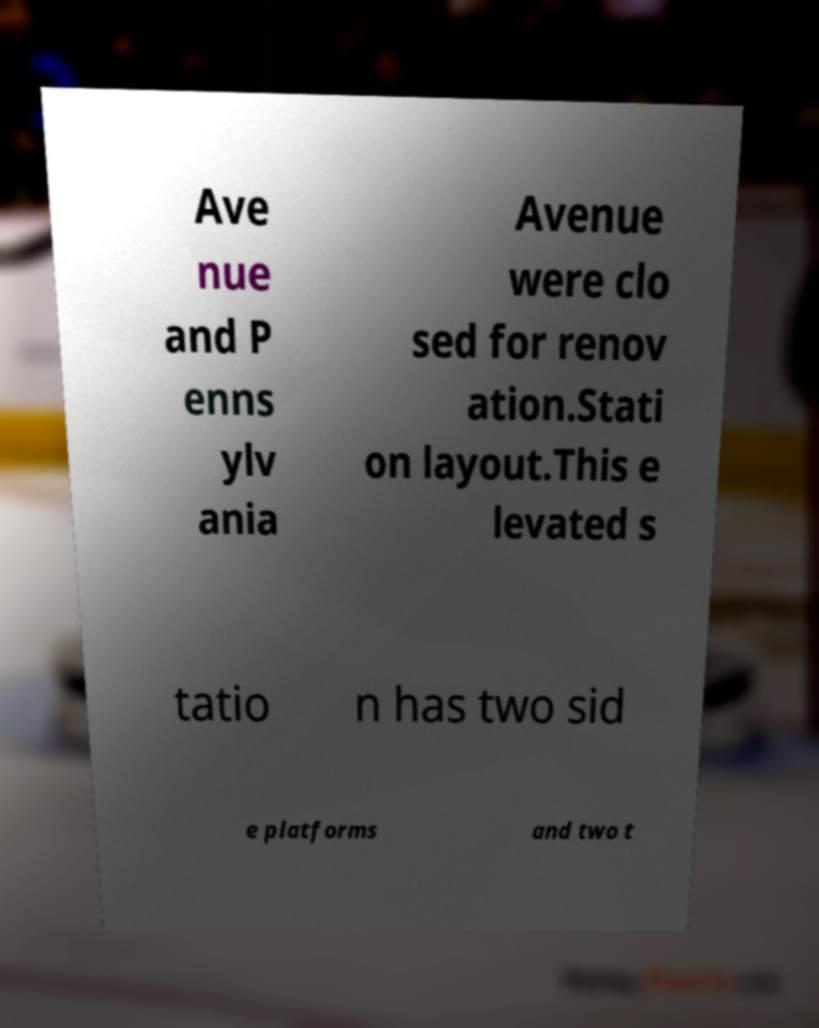What messages or text are displayed in this image? I need them in a readable, typed format. Ave nue and P enns ylv ania Avenue were clo sed for renov ation.Stati on layout.This e levated s tatio n has two sid e platforms and two t 